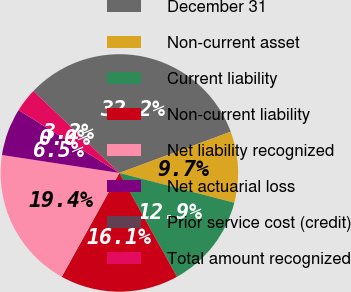Convert chart. <chart><loc_0><loc_0><loc_500><loc_500><pie_chart><fcel>December 31<fcel>Non-current asset<fcel>Current liability<fcel>Non-current liability<fcel>Net liability recognized<fcel>Net actuarial loss<fcel>Prior service cost (credit)<fcel>Total amount recognized<nl><fcel>32.24%<fcel>9.68%<fcel>12.9%<fcel>16.13%<fcel>19.35%<fcel>6.46%<fcel>0.01%<fcel>3.23%<nl></chart> 